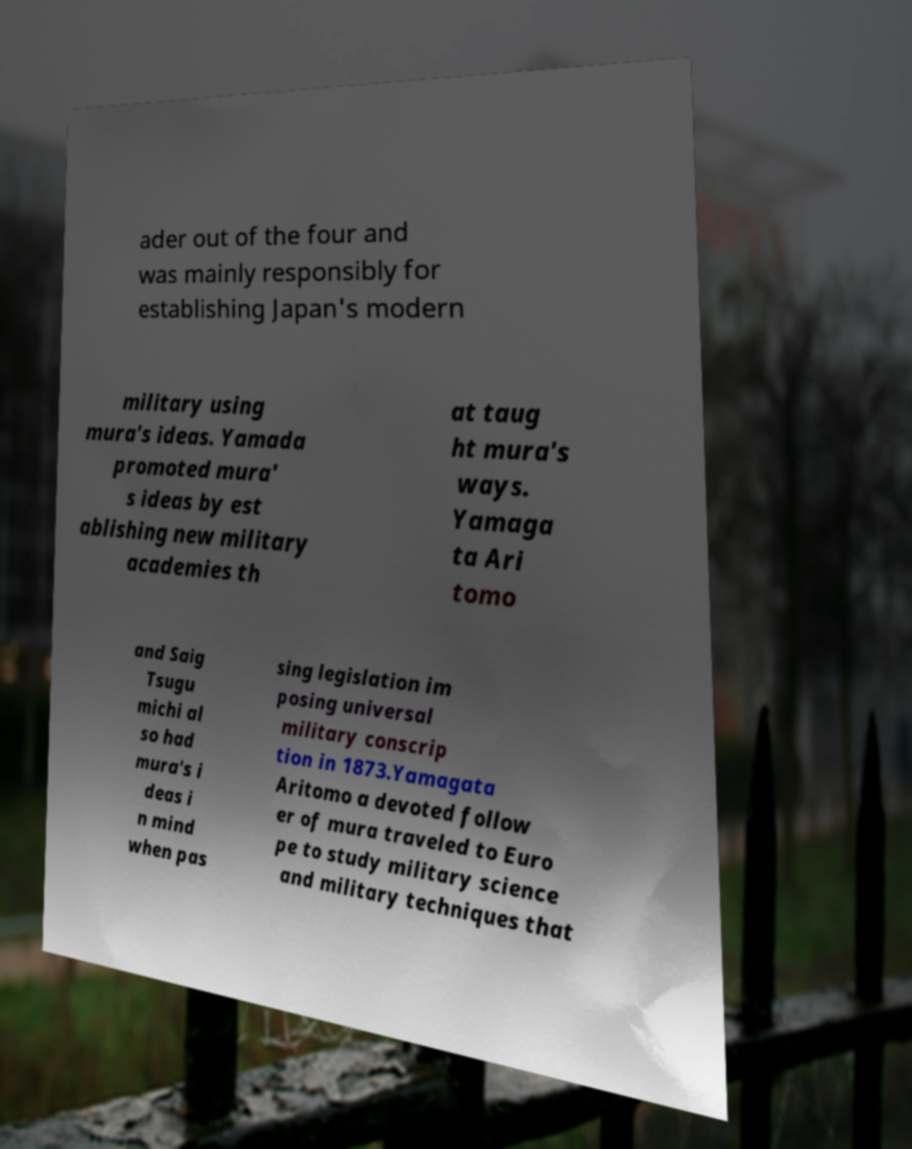What messages or text are displayed in this image? I need them in a readable, typed format. ader out of the four and was mainly responsibly for establishing Japan's modern military using mura's ideas. Yamada promoted mura' s ideas by est ablishing new military academies th at taug ht mura's ways. Yamaga ta Ari tomo and Saig Tsugu michi al so had mura's i deas i n mind when pas sing legislation im posing universal military conscrip tion in 1873.Yamagata Aritomo a devoted follow er of mura traveled to Euro pe to study military science and military techniques that 